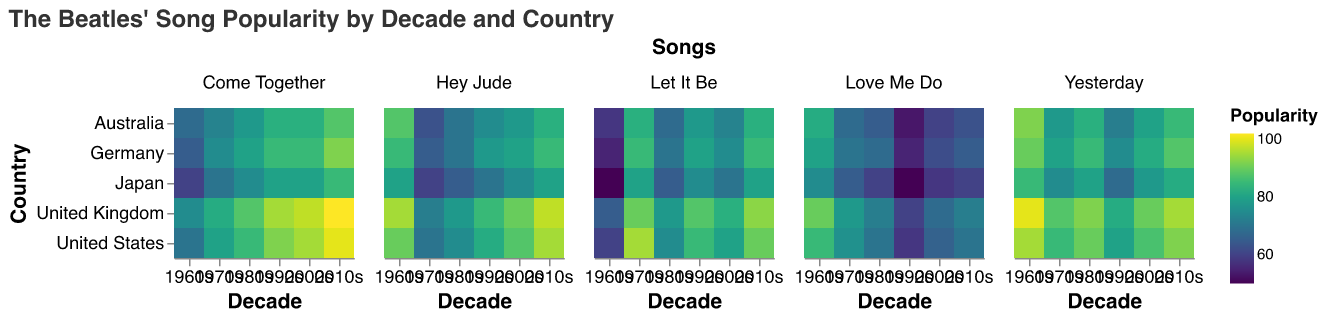What is the popularity of "Hey Jude" in the United Kingdom during the 2010s? Locate the "Hey Jude" song facet, then find the intersection of "2010s" on the x-axis and "United Kingdom" on the y-axis. The color intensity indicates the popularity score.
Answer: 97 Which song has the highest popularity in Japan during the 1960s? In the 1960s column under the Japan row, compare the color intensities of all songs in the Japan row. "Yesterday" has the highest popularity as indicated by its darker color.
Answer: Yesterday What is the combined popularity of "Let It Be" across all countries in the 1990s? Sum the popularity values of "Let It Be" for each country in the 1990s: 85 (US) + 88 (UK) + 80 (Germany) + 75 (Japan) + 78 (Australia). This yields a total of 85 + 88 + 80 + 75 + 78.
Answer: 406 Between "Love Me Do" and "Come Together", which song was more popular in the United States during the 1960s? Locate the United States row for the 1960s, then compare the color intensities of "Love Me Do" and "Come Together". "Love Me Do" has a score of 85, while "Come Together" has 70.
Answer: Love Me Do How has the popularity of "Yesterday" in Australia changed from the 1960s to the 2010s? Compare the value for "Yesterday" in Australia over the decades by looking at the color intensities: 92 (1960s), 78 (1970s), 83 (1980s), 72 (1990s), 80 (2000s), 85 (2010s).
Answer: Increased What is the average popularity of "Come Together" in Germany across all decades? Add up the popularity values for "Come Together" in Germany across all decades and divide by the number of decades: (65 + 75 + 80 + 85 + 85 + 92) / 6. Calculate: 482 / 6.
Answer: 80.33 Which country saw the largest increase in popularity for "Hey Jude" from the 1980s to the 2010s? Compare the popularity of "Hey Jude" in each country between the 1980s and 2010s, then calculate the differences: US (20), UK (19), Germany (15), Japan (15), Australia (13). The United States has the largest increase.
Answer: United States How does the popularity of "Let It Be" in the United Kingdom compare between the 1970s and the 1990s? Look at the color intensities for "Let It Be" in the United Kingdom during the 1970s and the 1990s. The popularity values are 90 (1970s) and 88 (1990s).
Answer: Decreased What is the most popular song in the United Kingdom during the 2000s? Locate the United Kingdom row for the 2000s and identify which song has the darkest color. "Come Together" has the highest score of 97.
Answer: Come Together 